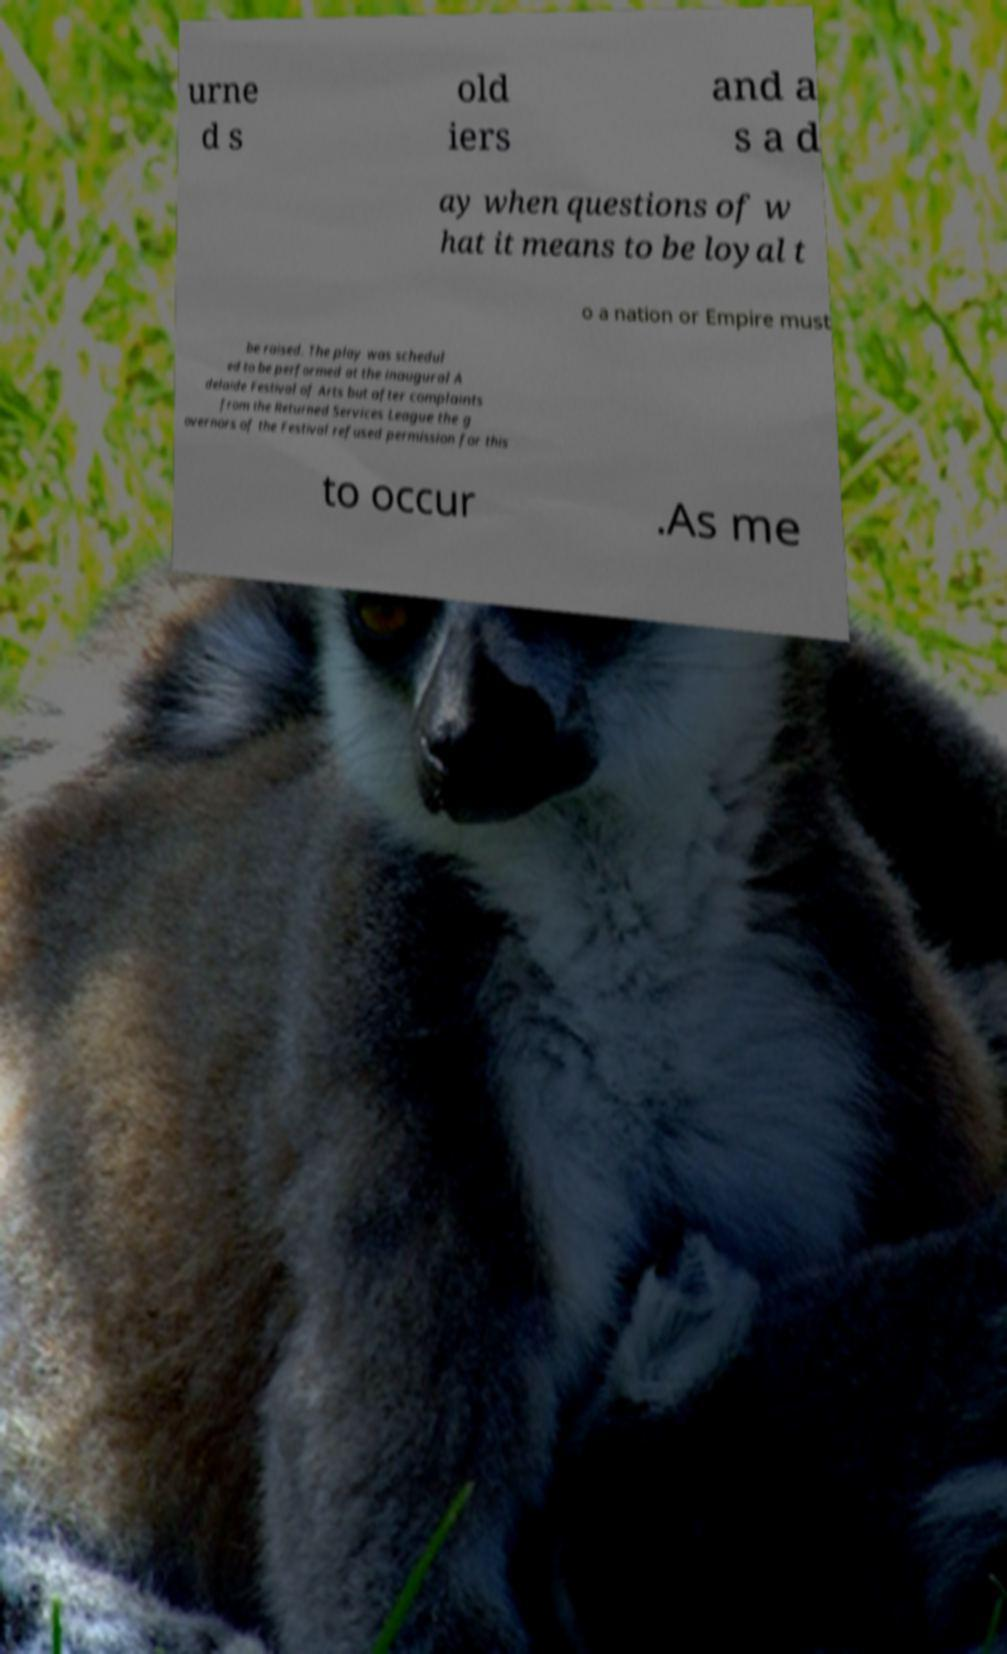Please read and relay the text visible in this image. What does it say? urne d s old iers and a s a d ay when questions of w hat it means to be loyal t o a nation or Empire must be raised. The play was schedul ed to be performed at the inaugural A delaide Festival of Arts but after complaints from the Returned Services League the g overnors of the Festival refused permission for this to occur .As me 